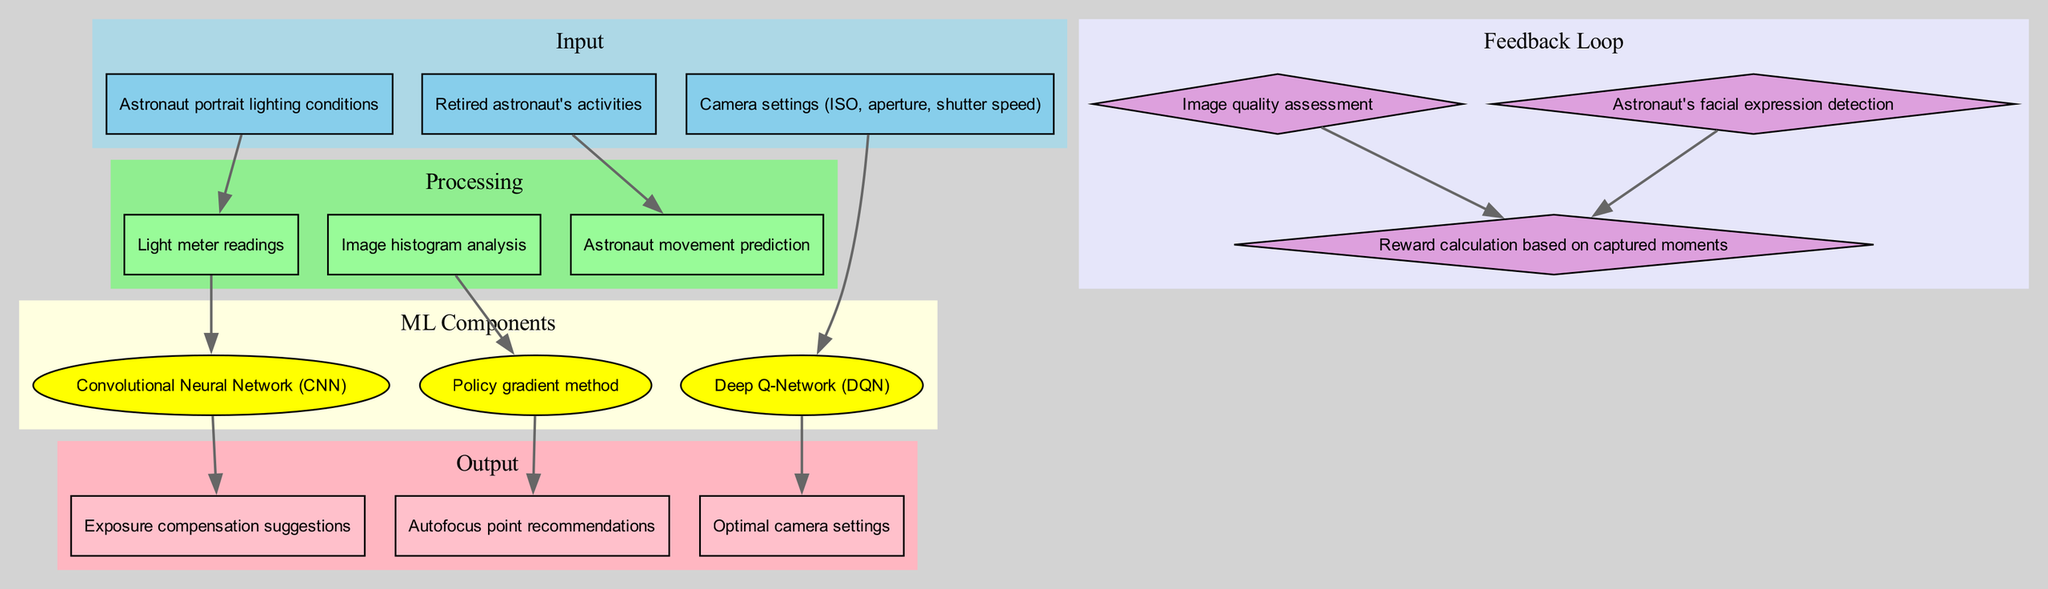what are the input nodes in the diagram? The input nodes in the diagram are listed under the "Input" section. They include "Astronaut portrait lighting conditions", "Camera settings (ISO, aperture, shutter speed)", and "Retired astronaut's activities".
Answer: Astronaut portrait lighting conditions, Camera settings (ISO, aperture, shutter speed), Retired astronaut's activities how many processing nodes are there? The processing nodes are "Light meter readings", "Image histogram analysis", and "Astronaut movement prediction". Counting these nodes gives a total of three.
Answer: 3 which node is connected to the Deep Q-Network? The node "Camera settings (ISO, aperture, shutter speed)" is directly connected to the "Deep Q-Network (DQN)" according to the connections outlined in the diagram.
Answer: Camera settings (ISO, aperture, shutter speed) what type of algorithm is represented by the DQN component? The Deep Q-Network (DQN) component is a type of reinforcement learning algorithm used in the optimization process within the diagram.
Answer: reinforcement learning how does image quality assessment influence the output? The "Image quality assessment" node contributes to the "Reward calculation based on captured moments". This feedback loop influences how well the captured images are evaluated, which in turn affects the optimal camera settings suggested by the DQN.
Answer: It influences reward calculation which output node is related to autofocus? The output node related to autofocus suggestions is "Autofocus point recommendations" in the diagram.
Answer: Autofocus point recommendations how is sunlight with low ISO related to light meter readings? Light meter readings are influenced by the current conditions of sunlight, which helps determine appropriate camera settings like lower ISO in bright light according to the diagram structure, as it optimizes capturing images of the astronaut.
Answer: They inform camera settings what method connects to exposure compensation suggestions? The "Convolutional Neural Network (CNN)" connects to "Exposure compensation suggestions", indicating that the CNN processes information to suggest compensation values for optimal exposure.
Answer: Convolutional Neural Network which feedback loop node detects facial expressions? The node "Astronaut's facial expression detection" is responsible for detecting the retired astronaut's facial expressions, which informs the feedback loop in the diagram.
Answer: Astronaut's facial expression detection 